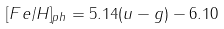Convert formula to latex. <formula><loc_0><loc_0><loc_500><loc_500>[ F e / H ] _ { p h } = 5 . 1 4 ( u - g ) - 6 . 1 0</formula> 